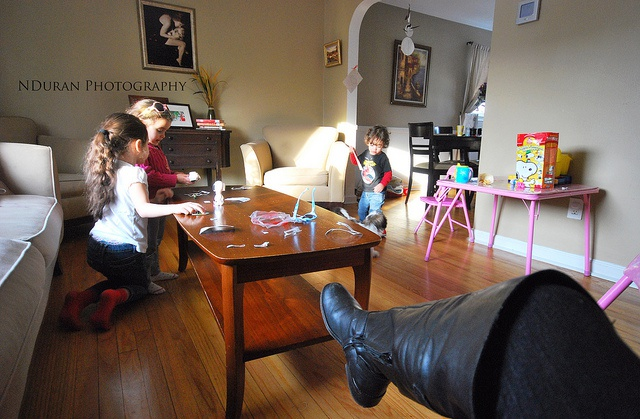Describe the objects in this image and their specific colors. I can see people in gray, black, and darkblue tones, dining table in gray, black, maroon, and brown tones, people in gray, black, and white tones, couch in gray, lightgray, darkgray, and black tones, and chair in gray, ivory, and tan tones in this image. 